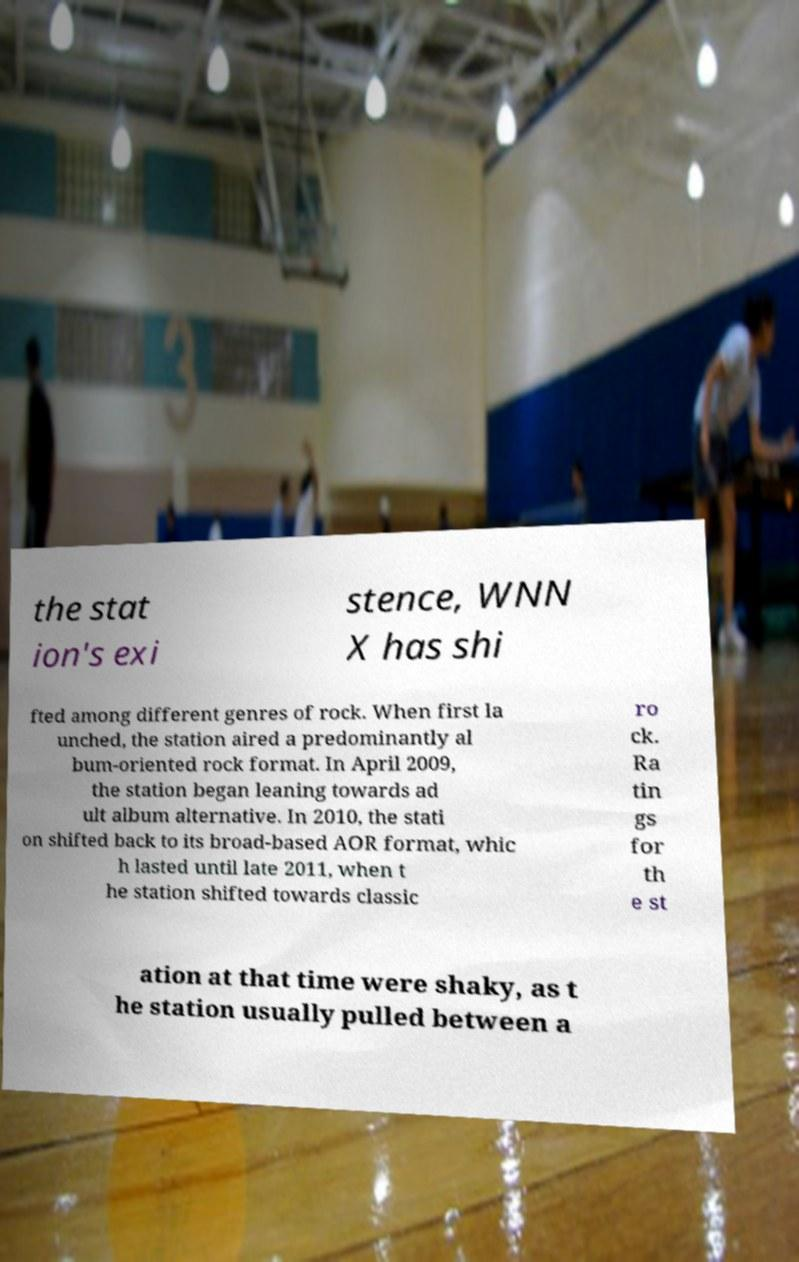Can you read and provide the text displayed in the image?This photo seems to have some interesting text. Can you extract and type it out for me? the stat ion's exi stence, WNN X has shi fted among different genres of rock. When first la unched, the station aired a predominantly al bum-oriented rock format. In April 2009, the station began leaning towards ad ult album alternative. In 2010, the stati on shifted back to its broad-based AOR format, whic h lasted until late 2011, when t he station shifted towards classic ro ck. Ra tin gs for th e st ation at that time were shaky, as t he station usually pulled between a 